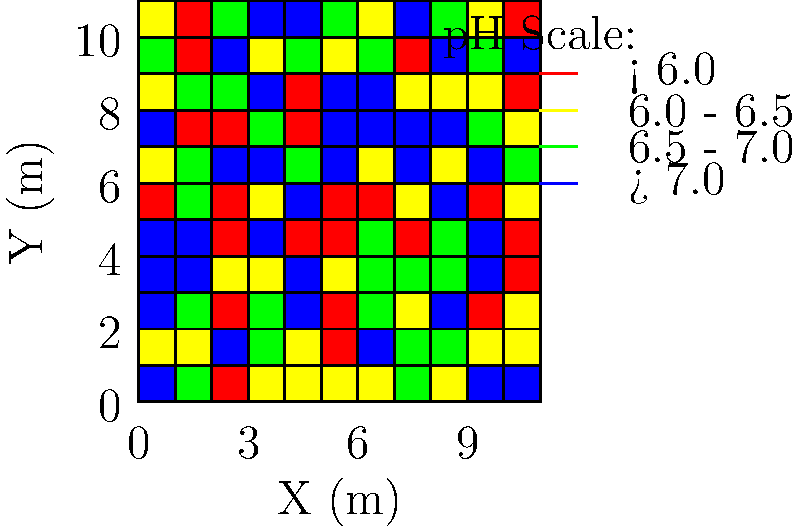Based on the color-coded soil pH map of a 10x10 meter field, what strategy would you recommend to a farmer looking to increase biodiversity in the areas with the lowest pH levels? To answer this question, let's follow these steps:

1. Interpret the pH map:
   - Red areas indicate pH < 6.0
   - Yellow areas indicate pH 6.0 - 6.5
   - Green areas indicate pH 6.5 - 7.0
   - Blue areas indicate pH > 7.0

2. Identify the areas with the lowest pH:
   - The red areas have the lowest pH (< 6.0), which is considered acidic.

3. Understand the impact of low pH on biodiversity:
   - Acidic soils can limit plant diversity and microbial activity.
   - Many beneficial soil organisms prefer pH ranges between 6.0 and 7.0.

4. Consider strategies to increase pH and promote biodiversity:
   - Liming: Adding calcium carbonate (lime) can raise soil pH.
   - Organic matter: Incorporating compost or well-rotted manure can help buffer pH and improve soil structure.
   - Cover crops: Planting legumes can help fix nitrogen and gradually increase pH.

5. Recommend a comprehensive approach:
   - Apply lime to the red areas to raise pH.
   - Incorporate organic matter throughout the field.
   - Use cover crops, especially legumes, in the rotation.
   - Monitor pH levels regularly and adjust management practices as needed.

This strategy will help increase the pH in the most acidic areas, improve overall soil health, and create more favorable conditions for a diverse range of plants and soil organisms.
Answer: Apply lime to acidic areas, incorporate organic matter, and use leguminous cover crops. 